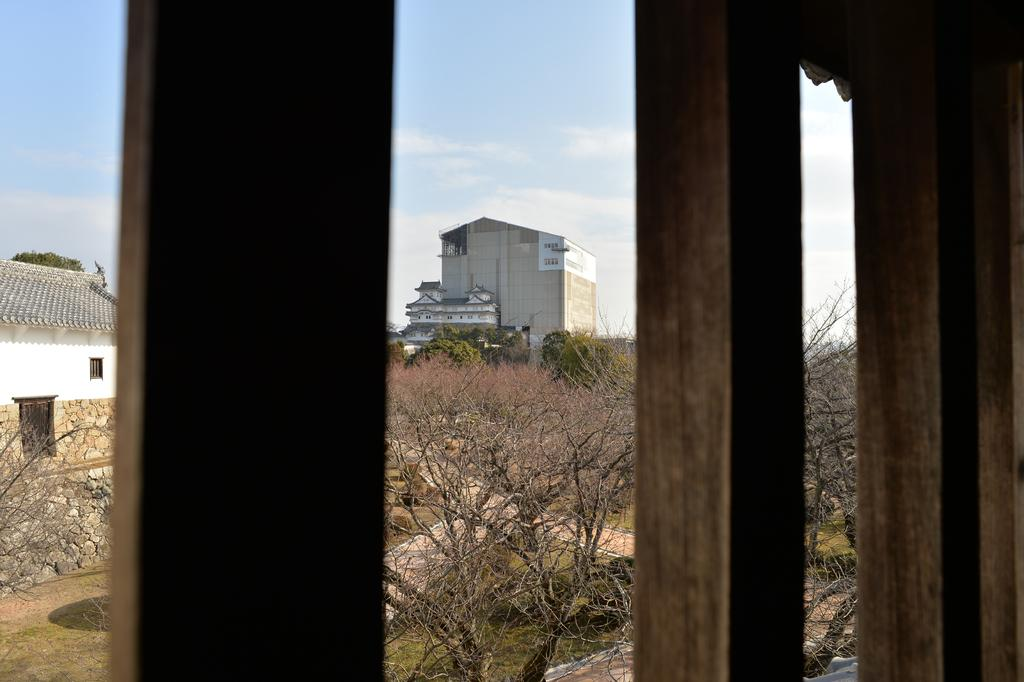What objects can be seen in the front of the image? There are wooden sticks in the front of the image. What type of structure is visible in the background of the image? There is a building in the background of the image. What natural elements can be seen in the background of the image? There are trees and plants in the background of the image. What type of surface is visible at the bottom of the image? There is ground visible at the bottom of the image. What type of quiver is hanging on the tree in the image? There is no quiver present in the image; it features wooden sticks, a building, trees, plants, and ground. What nerve is responsible for the movement of the wooden sticks in the image? There is no nerve involved in the movement of the wooden sticks, as they are stationary objects in the image. 